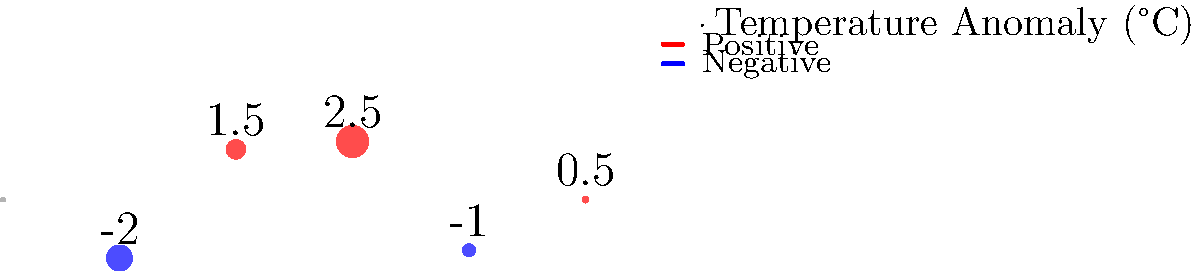Given the global map projection showing temperature anomalies, calculate the average temperature anomaly for the Northern Hemisphere. Assume that each point represents an equal area of the Earth's surface. To solve this problem, we need to follow these steps:

1. Identify the points in the Northern Hemisphere:
   - Point 1: 60°N, 0°E with anomaly of 2.5°C
   - Point 2: 30°N, 60°W with anomaly of 1.5°C

2. Calculate the average of these two points:
   $$ \text{Average} = \frac{\text{Sum of anomalies}}{\text{Number of points}} $$
   $$ \text{Average} = \frac{2.5°C + 1.5°C}{2} = \frac{4°C}{2} = 2°C $$

3. Consider the assumptions:
   - We assume each point represents an equal area of the Earth's surface.
   - This is a simplification, as in reality, the area represented by each point would vary with latitude due to the map projection.

4. Interpret the result:
   The average temperature anomaly for the Northern Hemisphere, based on the given data points and assumptions, is 2°C.

It's important to note that this is a simplified calculation. In actual climate modeling:
- Many more data points would be used.
- The area represented by each point would be weighted according to its latitude.
- More sophisticated statistical methods would be employed to account for spatial variations and data gaps.
Answer: 2°C 